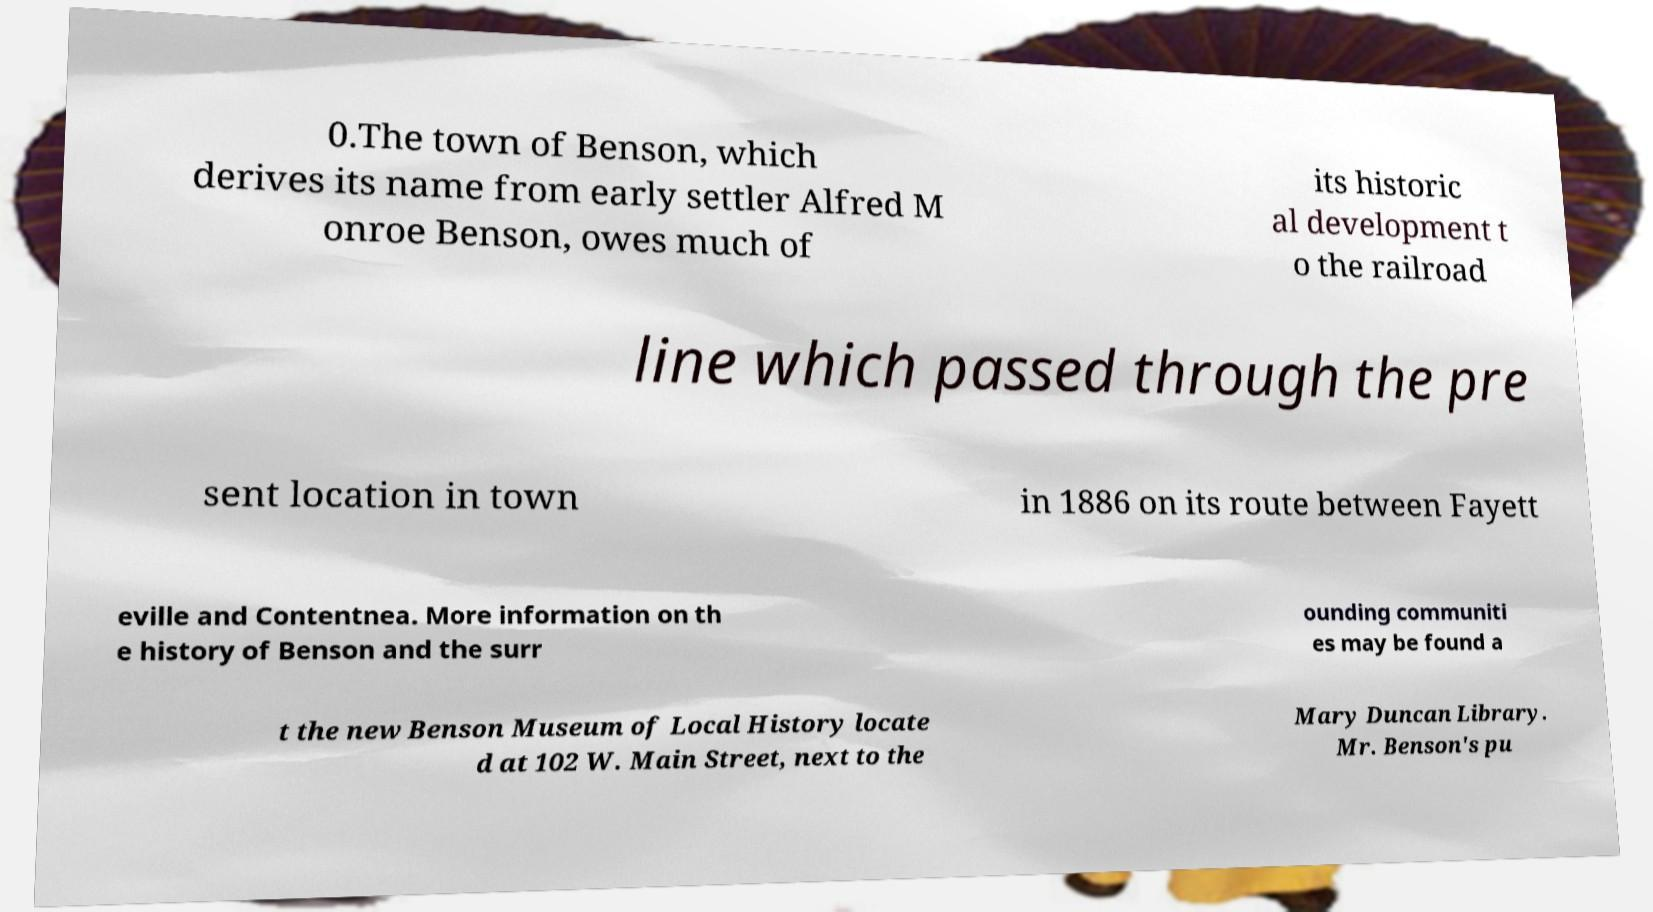Could you assist in decoding the text presented in this image and type it out clearly? 0.The town of Benson, which derives its name from early settler Alfred M onroe Benson, owes much of its historic al development t o the railroad line which passed through the pre sent location in town in 1886 on its route between Fayett eville and Contentnea. More information on th e history of Benson and the surr ounding communiti es may be found a t the new Benson Museum of Local History locate d at 102 W. Main Street, next to the Mary Duncan Library. Mr. Benson's pu 